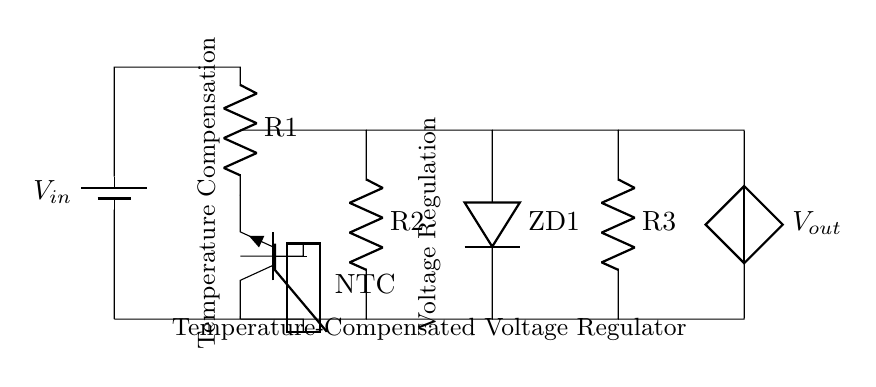What type of components are used for voltage regulation in this circuit? The circuit diagram shows a transistor (noted as Tnpn), a zener diode (noted as ZD1), and resistors (noted as R1, R2, and R3). These components work together to regulate the output voltage.
Answer: Transistor, zener diode, resistors What is the role of the thermistor in this circuit? The thermistor, labeled as NTC (negative temperature coefficient), adjusts the circuit's behavior based on temperature changes. As temperature increases, the resistance decreases, which helps to stabilize the output voltage under varying thermal conditions.
Answer: Temperature compensation How many resistors are present in the circuit? The circuit includes three resistors labeled as R1, R2, and R3. Each resistor plays a role in voltage division and stability in the regulation process.
Answer: Three What is the connection type used between the battery and the components? The connection type is a series connection, where all components are connected along a singular path. This ensures that the same current flows through each component, which is typical for this type of voltage regulator setup.
Answer: Series connection How does the zener diode affect the circuit operation? The zener diode (ZD1) provides a stable reference voltage, preventing the output voltage from exceeding a certain level. It clamps the voltage, ensuring that it doesn't rise above the zener voltage, thus contributing to voltage regulation despite fluctuations in input voltage.
Answer: Voltage clamping 